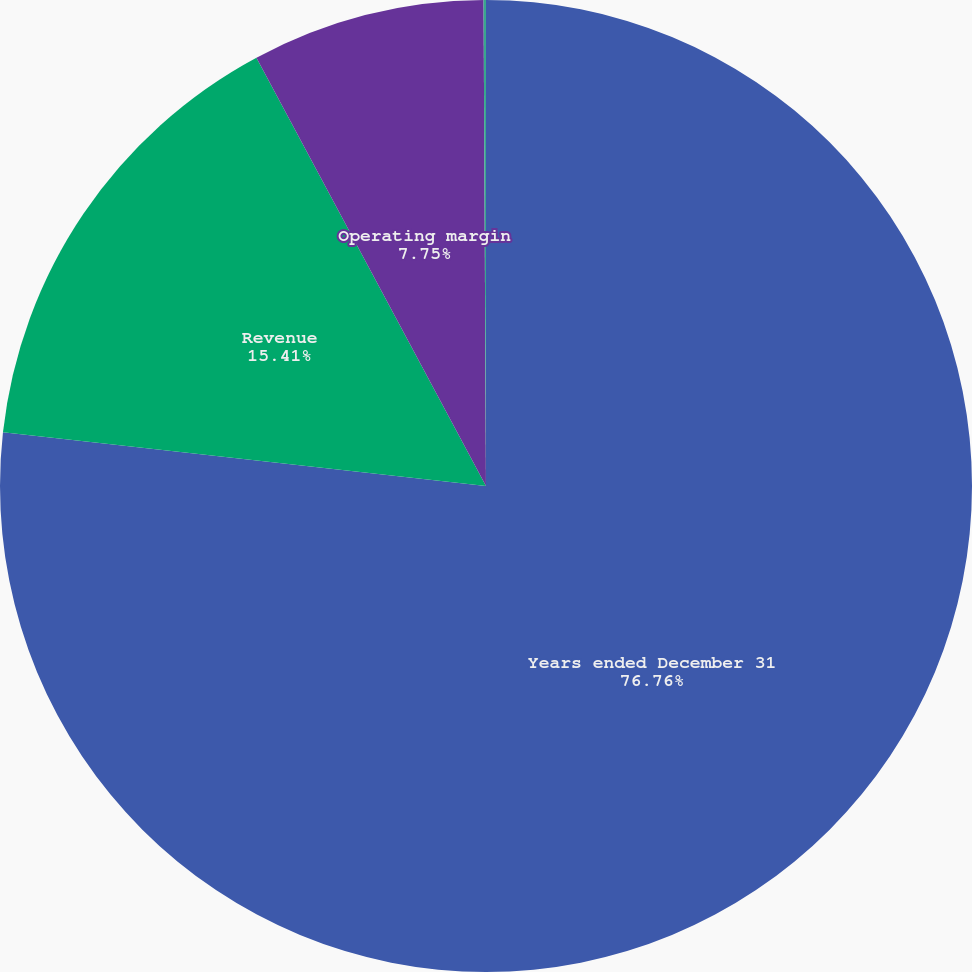Convert chart. <chart><loc_0><loc_0><loc_500><loc_500><pie_chart><fcel>Years ended December 31<fcel>Revenue<fcel>Operating margin<fcel>Net income (loss)<nl><fcel>76.76%<fcel>15.41%<fcel>7.75%<fcel>0.08%<nl></chart> 